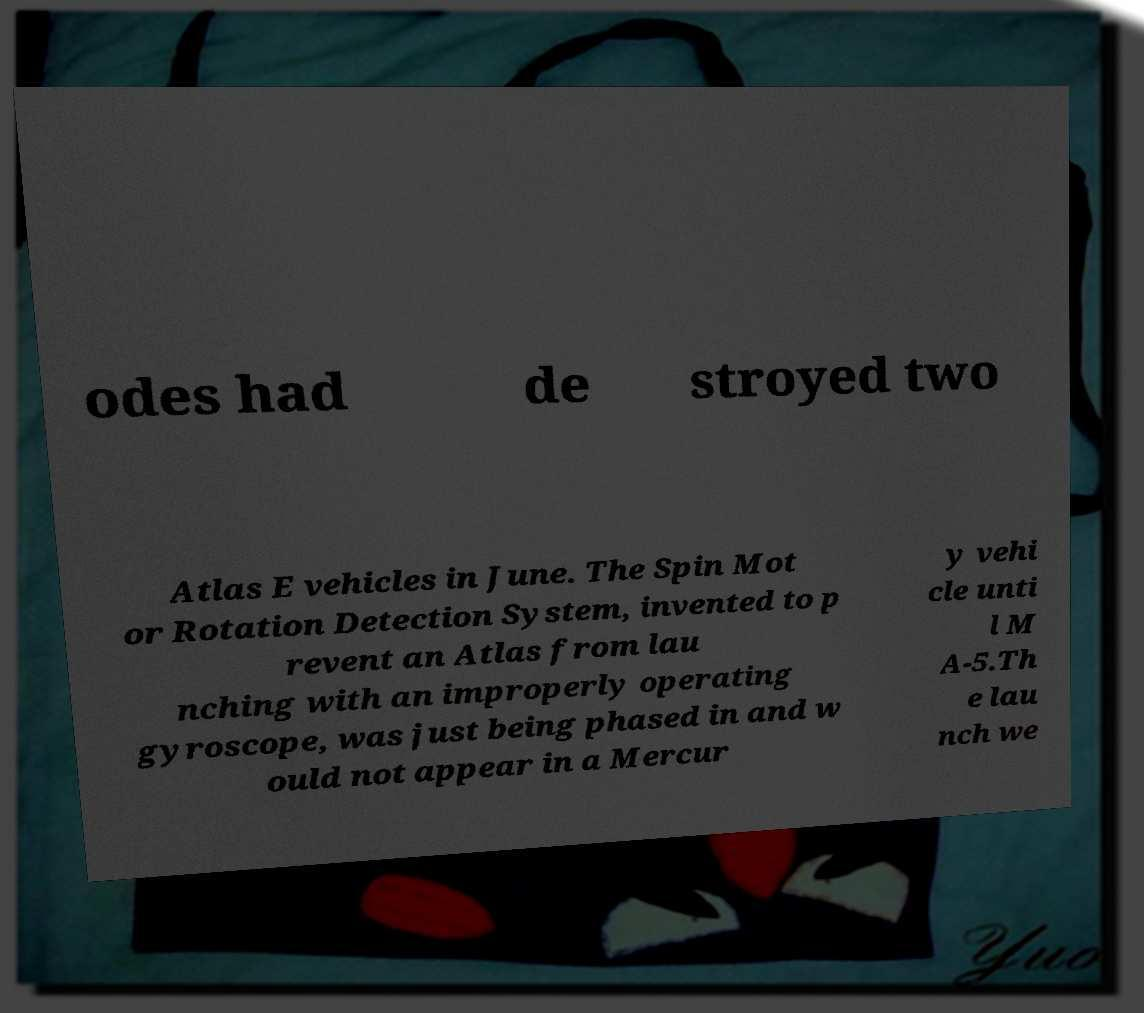Can you read and provide the text displayed in the image?This photo seems to have some interesting text. Can you extract and type it out for me? odes had de stroyed two Atlas E vehicles in June. The Spin Mot or Rotation Detection System, invented to p revent an Atlas from lau nching with an improperly operating gyroscope, was just being phased in and w ould not appear in a Mercur y vehi cle unti l M A-5.Th e lau nch we 